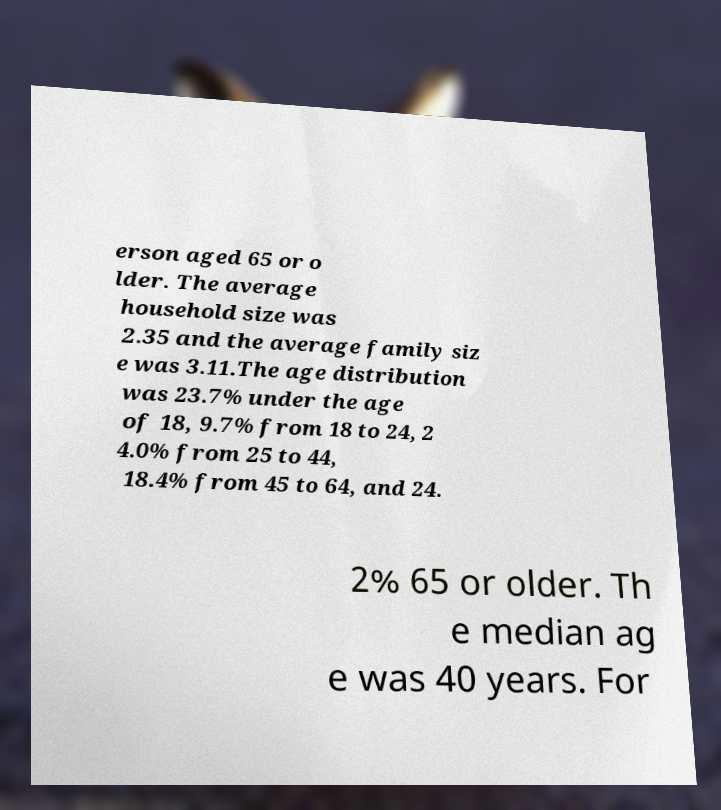I need the written content from this picture converted into text. Can you do that? erson aged 65 or o lder. The average household size was 2.35 and the average family siz e was 3.11.The age distribution was 23.7% under the age of 18, 9.7% from 18 to 24, 2 4.0% from 25 to 44, 18.4% from 45 to 64, and 24. 2% 65 or older. Th e median ag e was 40 years. For 